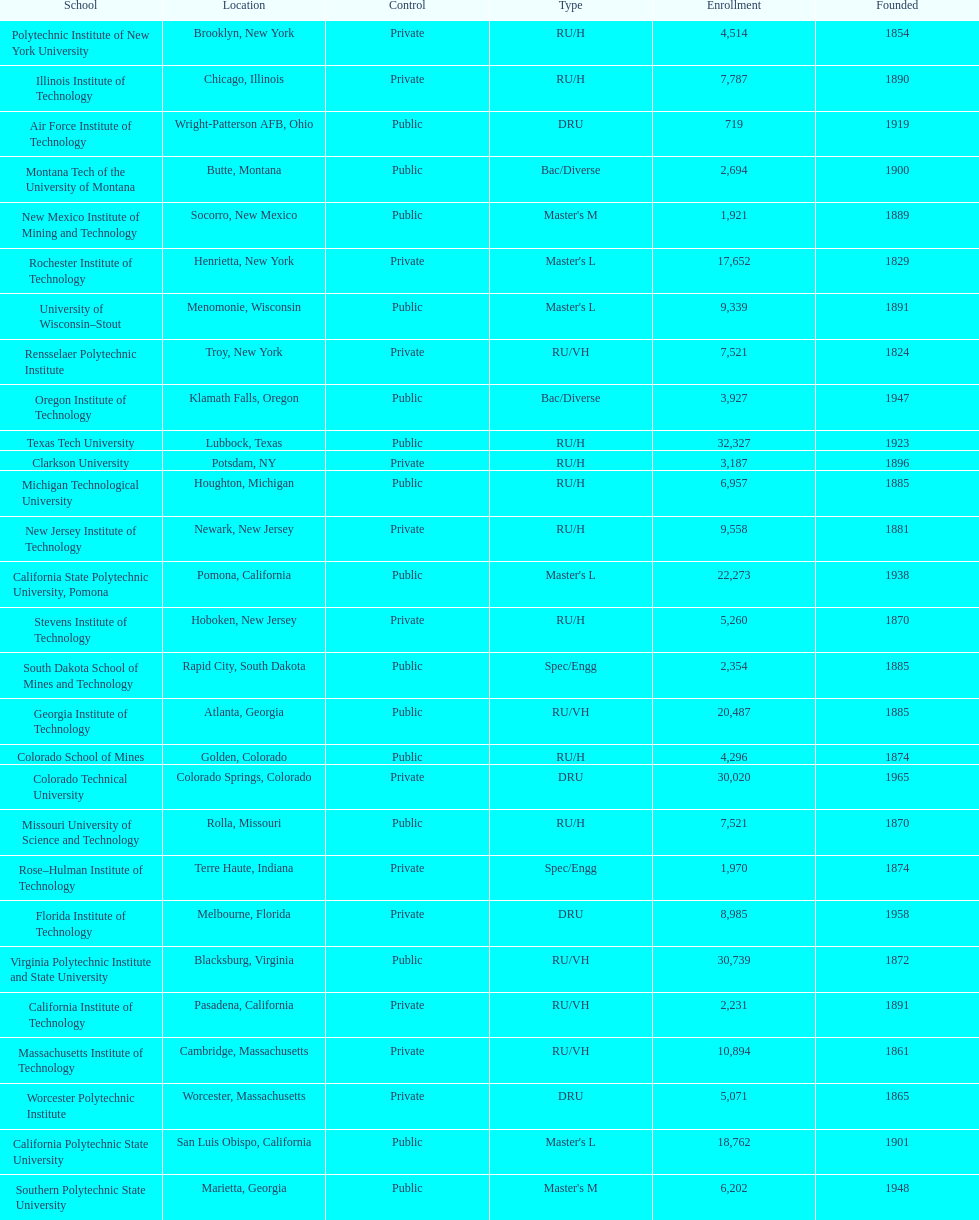Which of the universities was founded first? Rensselaer Polytechnic Institute. 